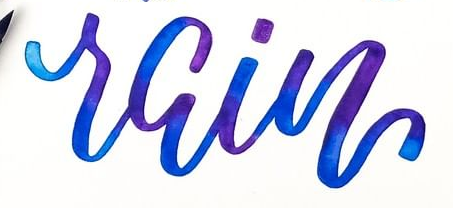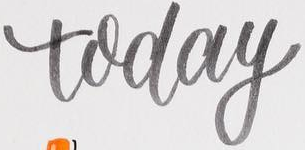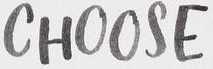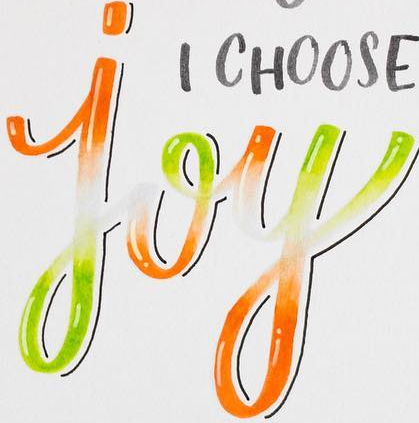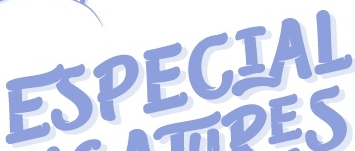Transcribe the words shown in these images in order, separated by a semicolon. rain; today; CHOOSE; joy; ESPECIAL 